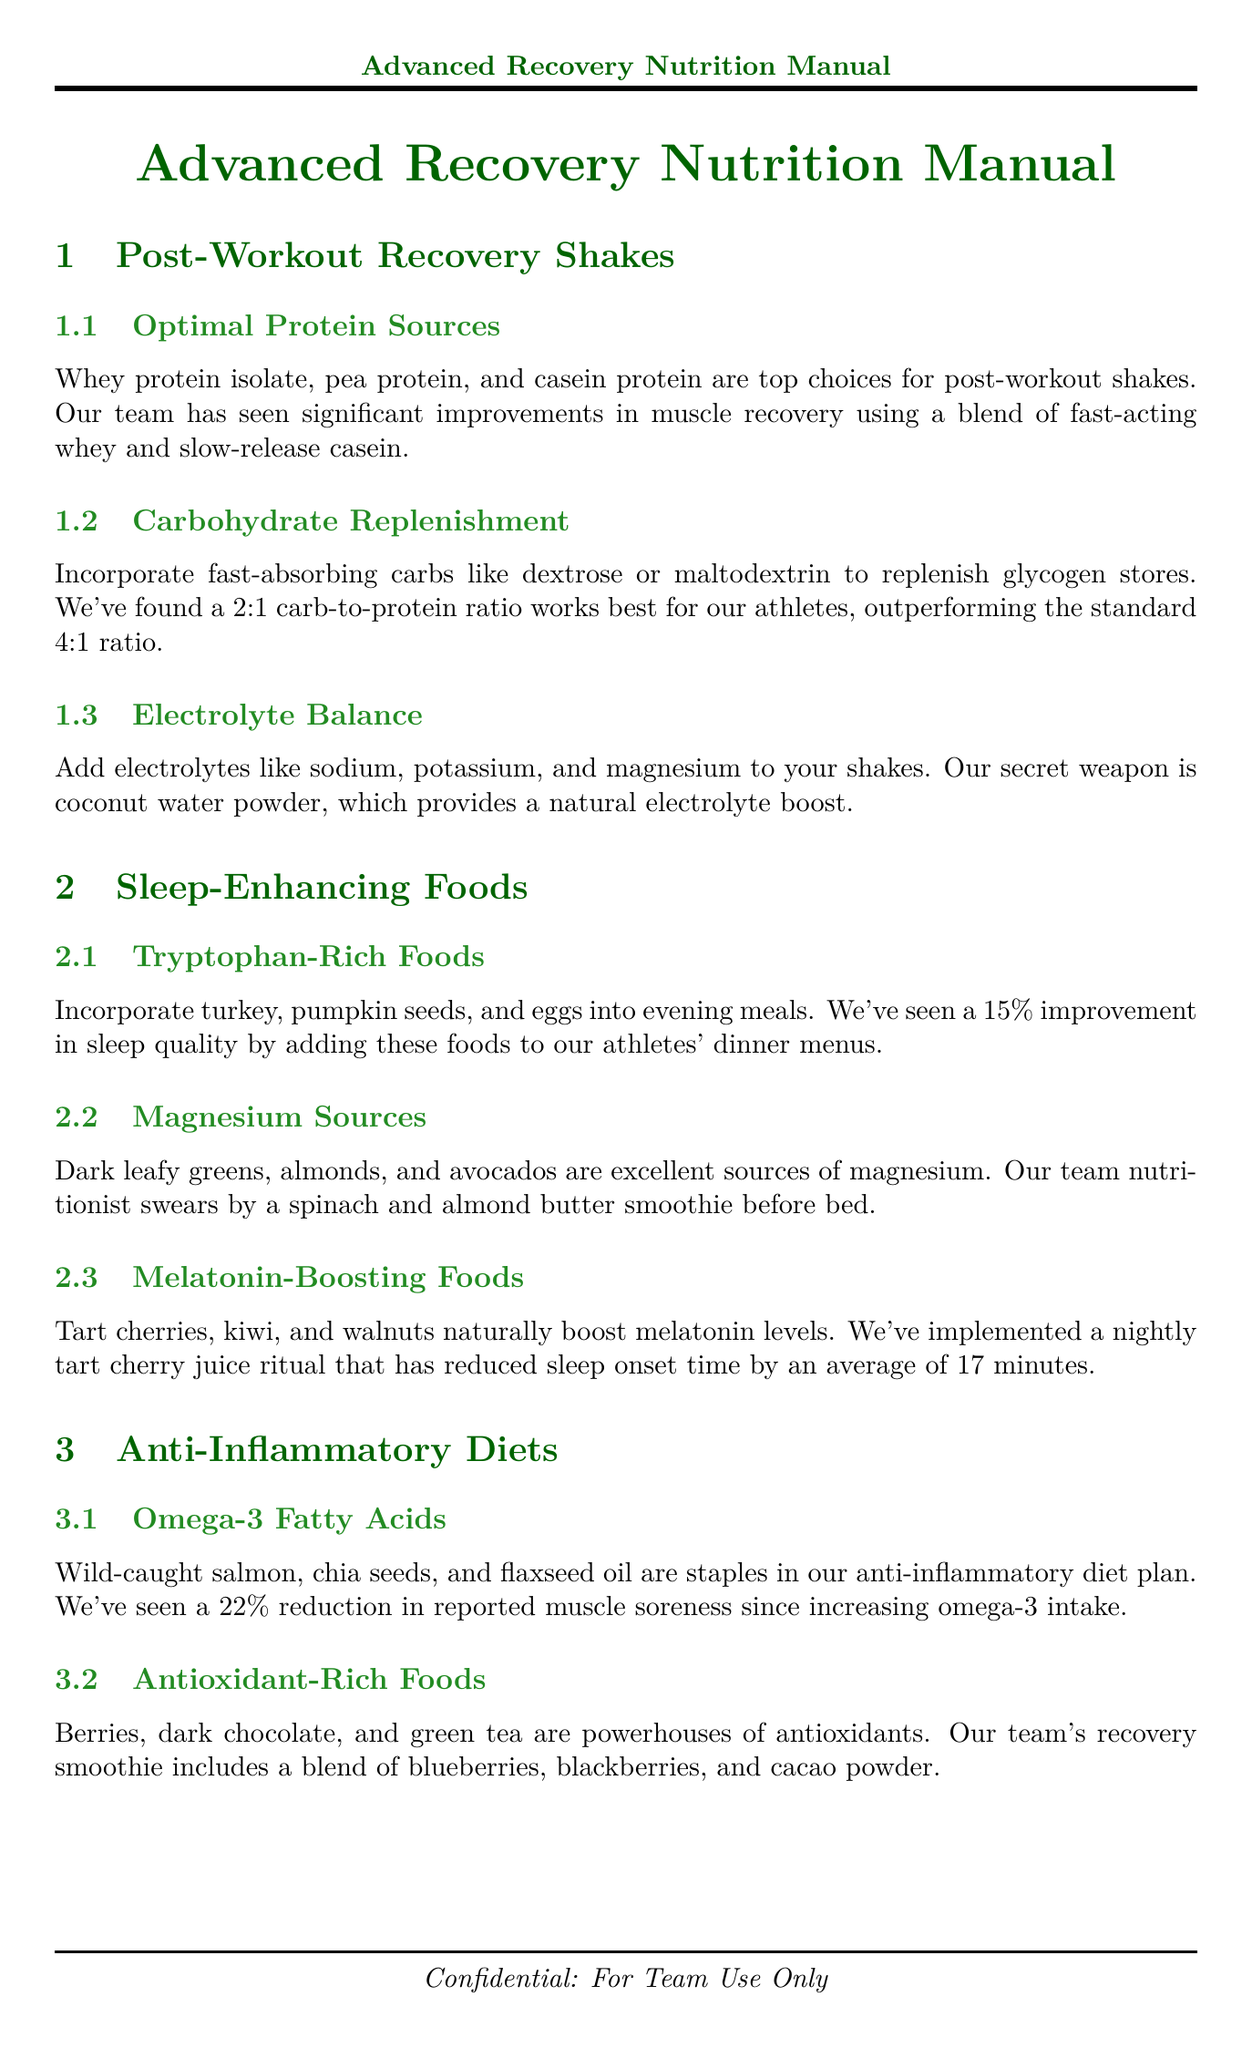what is a top choice for post-workout protein? The document states that whey protein isolate is a top choice for post-workout shakes.
Answer: whey protein isolate what is the best carb-to-protein ratio suggested? The document mentions that a 2:1 carb-to-protein ratio works best for athletes.
Answer: 2:1 which food is rich in melatonin? The document lists tart cherries as a food that naturally boosts melatonin levels.
Answer: tart cherries how much did sleep quality improve with tryptophan-rich foods? The document indicates a 15% improvement in sleep quality by adding these foods.
Answer: 15% what supplement is used for anti-inflammatory purposes? The document describes a proprietary turmeric and ginger supplement for reducing inflammation markers.
Answer: turmeric and ginger supplement which electrolyte is highlighted as a "secret weapon"? The document refers to coconut water powder as their secret weapon for electrolyte balance.
Answer: coconut water powder what was the improvement in morning hydration levels? The document states that morning hydration levels improved by 8%.
Answer: 8% how much casein protein is in the pre-sleep shake? The document mentions that the pre-sleep protein shake contains 40g of casein protein.
Answer: 40g what dietary approach does the team use on rest days? The document states that lower carb intake is used on rest days as part of the carb cycling approach.
Answer: lower carb intake 